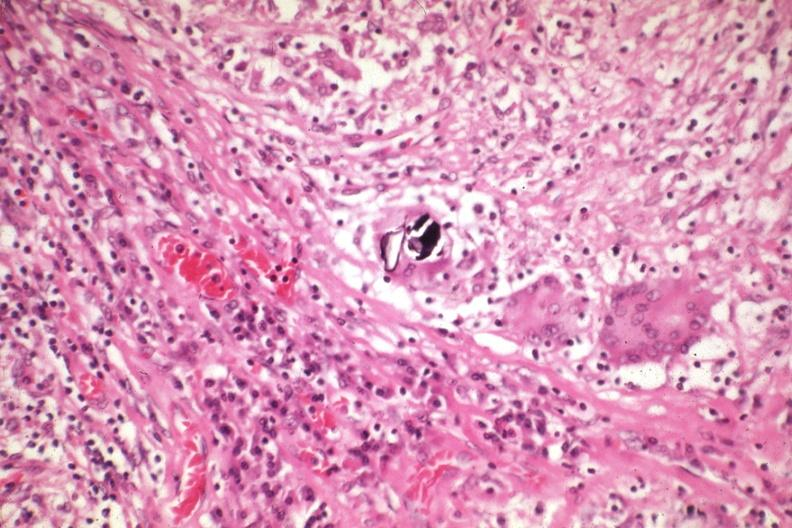s lymph node present?
Answer the question using a single word or phrase. Yes 